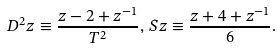<formula> <loc_0><loc_0><loc_500><loc_500>D ^ { 2 } z \equiv \frac { z - 2 + z ^ { - 1 } } { T ^ { 2 } } , \, S z \equiv \frac { z + 4 + z ^ { - 1 } } 6 .</formula> 